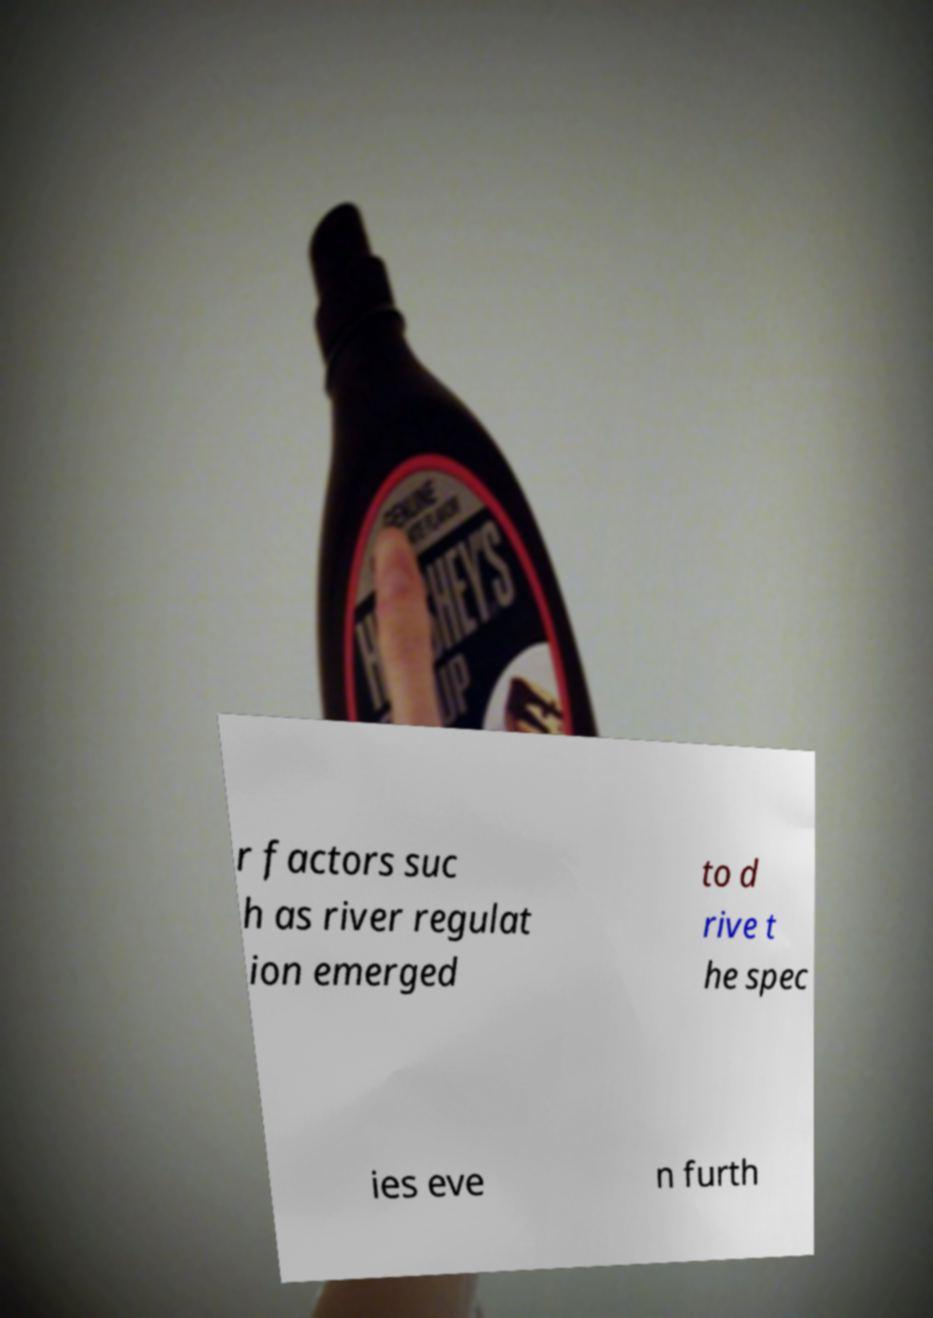There's text embedded in this image that I need extracted. Can you transcribe it verbatim? r factors suc h as river regulat ion emerged to d rive t he spec ies eve n furth 